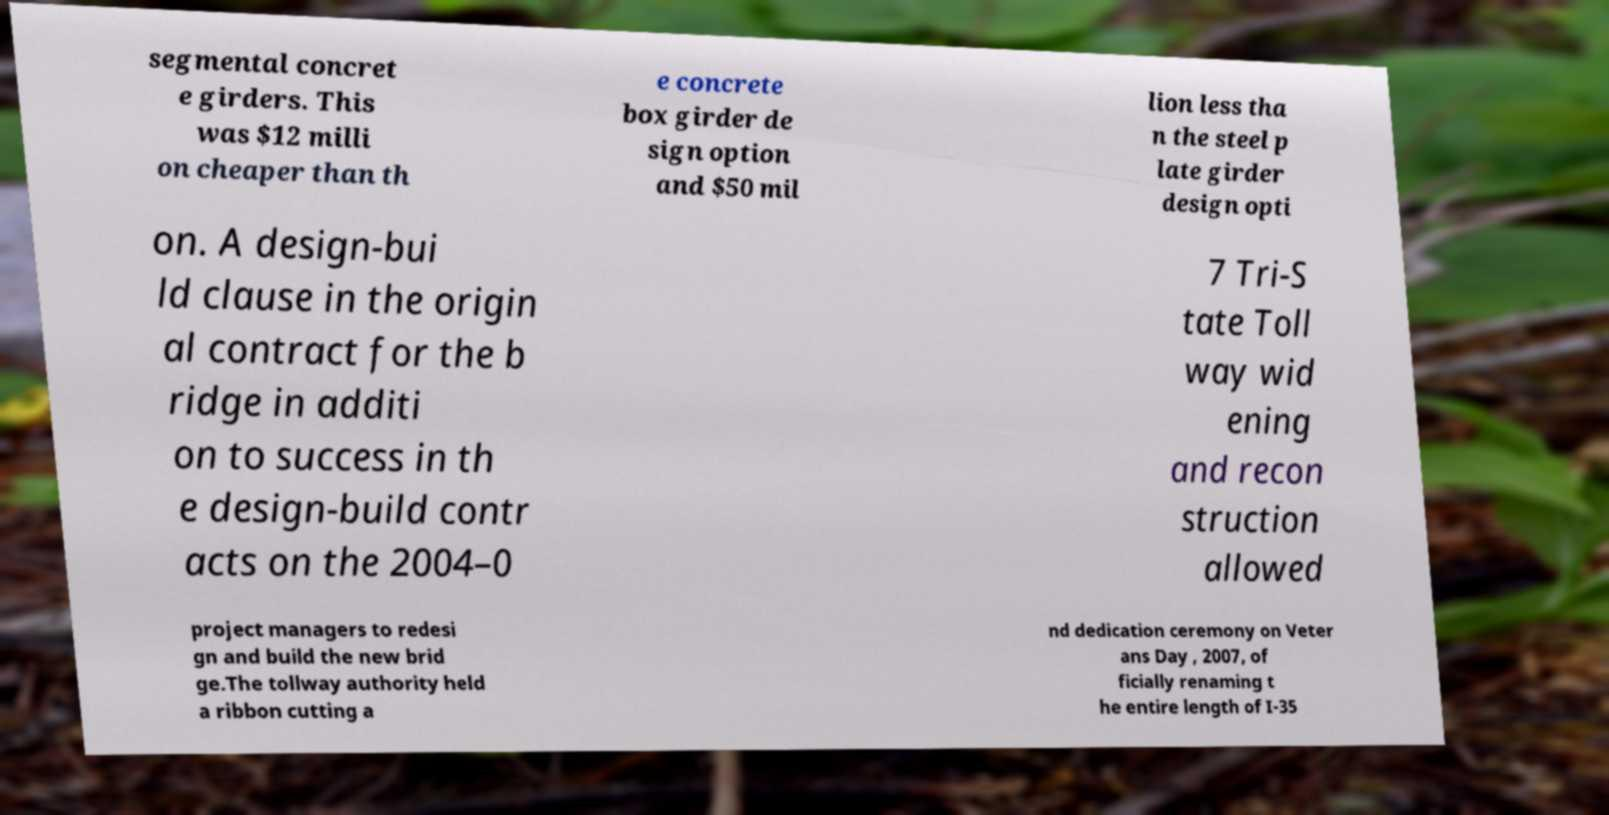Could you extract and type out the text from this image? segmental concret e girders. This was $12 milli on cheaper than th e concrete box girder de sign option and $50 mil lion less tha n the steel p late girder design opti on. A design-bui ld clause in the origin al contract for the b ridge in additi on to success in th e design-build contr acts on the 2004–0 7 Tri-S tate Toll way wid ening and recon struction allowed project managers to redesi gn and build the new brid ge.The tollway authority held a ribbon cutting a nd dedication ceremony on Veter ans Day , 2007, of ficially renaming t he entire length of I-35 